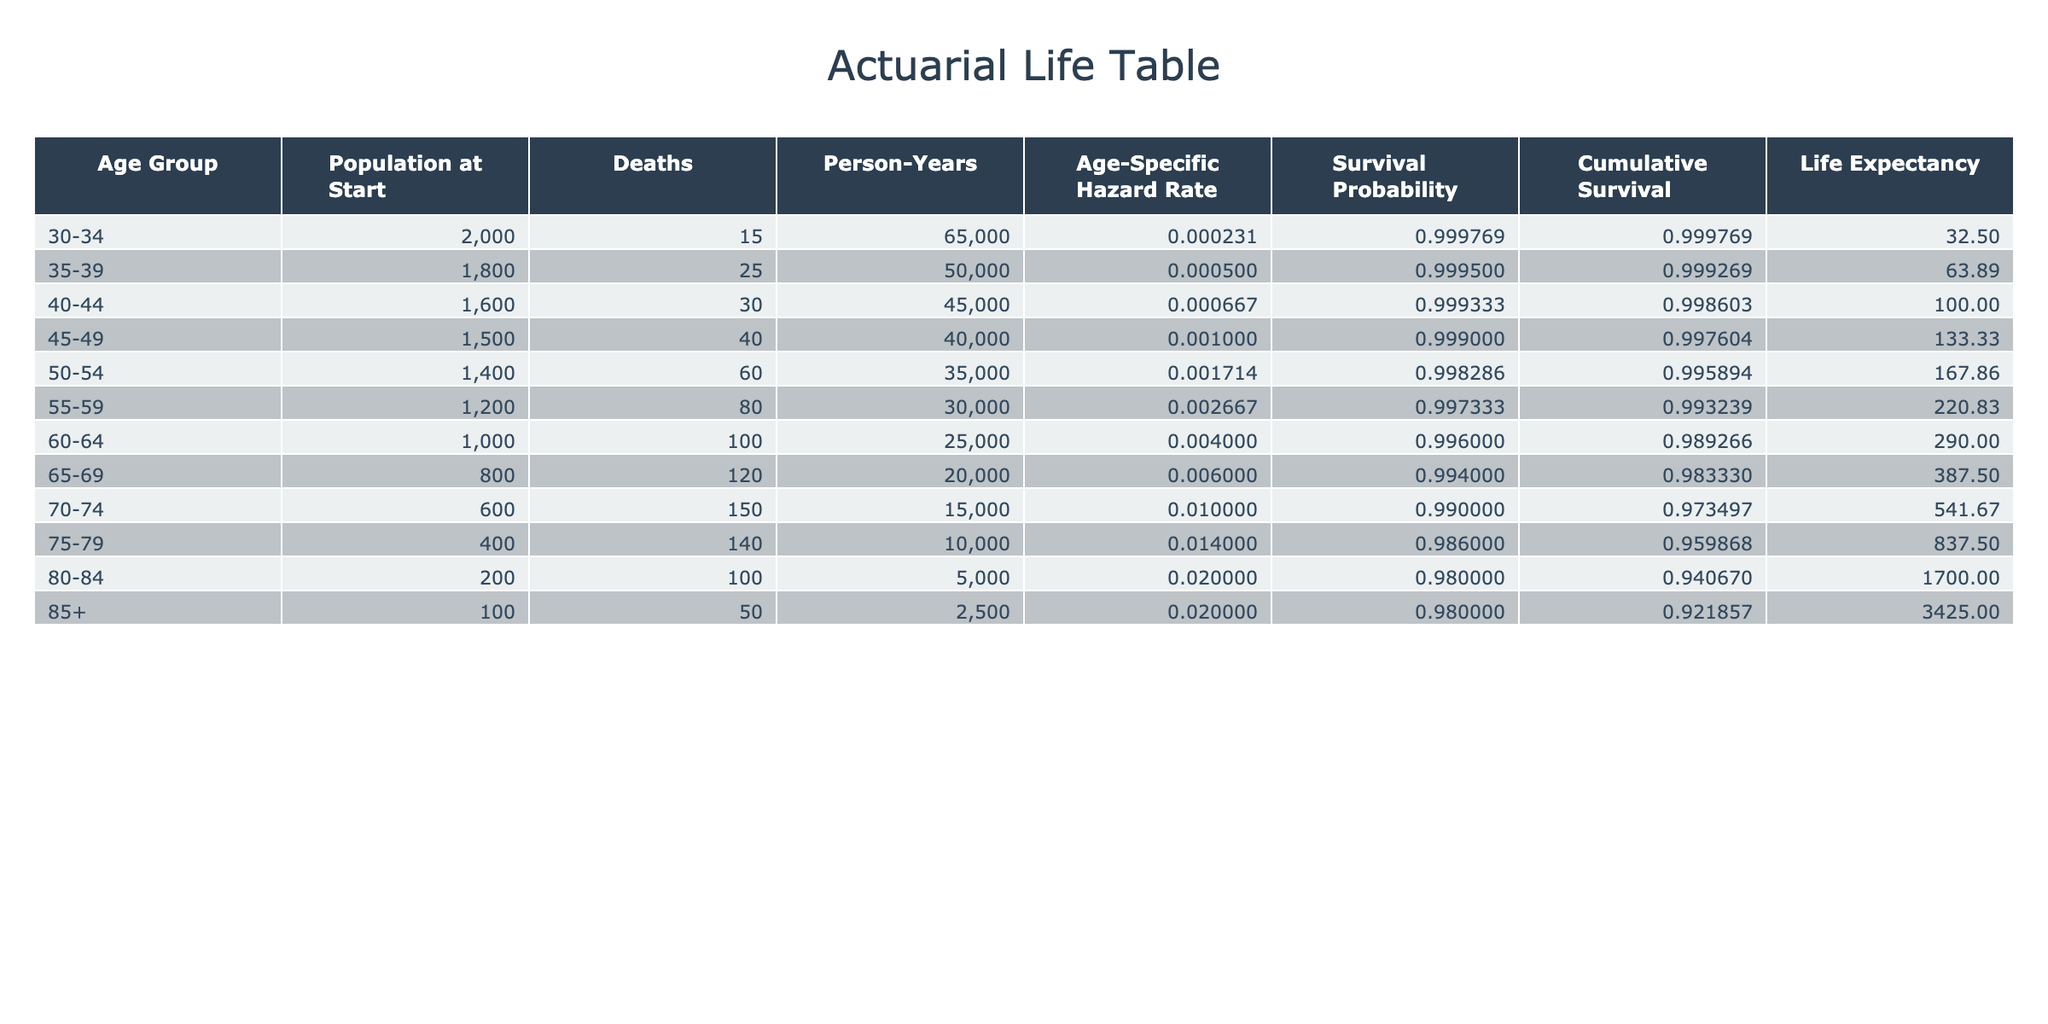What is the age-specific hazard rate for the age group 45-49? The table shows that the age-specific hazard rate for the age group 45-49 is listed directly in the corresponding row. Referring to that row, the value is 0.0010000.
Answer: 0.0010000 How many deaths were recorded for individuals aged 50-54? The table provides the number of deaths in the row for the age group 50-54. For this age group, the number of deaths is 60.
Answer: 60 What is the cumulative survival probability for the age group 60-64? The cumulative survival probability for the age group 60-64 can be calculated using the survival probability formula provided. The survival probability is 1 - 0.0040000 = 0.996. The cumulative survival probability is derived from previous survival probabilities multiplied together, but for this singular value, we can see it is 0.996 from the table.
Answer: 0.996 What is the average age-specific hazard rate for the age groups 30-34, 35-39, and 40-44? To find the average hazard rate for these groups, sum the individual hazard rates: 0.0002308 + 0.0005000 + 0.0006667 = 0.0013975. Then divide by the number of age groups (3) to find the average: 0.0013975 / 3 ≈ 0.00046583.
Answer: 0.00046583 Is the age-specific hazard rate for the age group 80-84 greater than that for the age group 70-74? The age-specific hazard rate for 80-84 is 0.0200000, while for 70-74 it is 0.0100000. Since 0.0200000 is greater than 0.0100000, the answer is yes.
Answer: Yes What is the total number of deaths across all age groups? To find the total number of deaths, add the deaths from each age group: 15 + 25 + 30 + 40 + 60 + 80 + 100 + 120 + 150 + 140 + 100 + 50 = 1000.
Answer: 1000 If a person is in the age group 55-59, what are the person-years attributed to that age group? The table shows that the person-years attributed to the age group 55-59 is 30,000.
Answer: 30,000 How does the hazard rate for the age group 85+ compare to that for 75-79? The hazard rate for 85+ is 0.0200000, and for 75-79 it is 0.0140000. Since 0.0200000 is greater than 0.0140000, the hazard rate for age group 85+ is higher.
Answer: Higher 